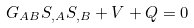<formula> <loc_0><loc_0><loc_500><loc_500>G _ { A B } S _ { , A } S _ { , B } + V + Q = 0</formula> 